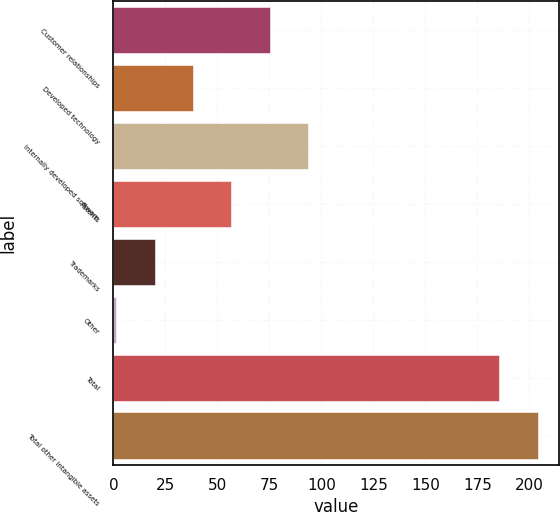Convert chart to OTSL. <chart><loc_0><loc_0><loc_500><loc_500><bar_chart><fcel>Customer relationships<fcel>Developed technology<fcel>Internally developed software<fcel>Patents<fcel>Trademarks<fcel>Other<fcel>Total<fcel>Total other intangible assets<nl><fcel>75.08<fcel>38.24<fcel>93.5<fcel>56.66<fcel>19.82<fcel>1.4<fcel>185.6<fcel>204.02<nl></chart> 